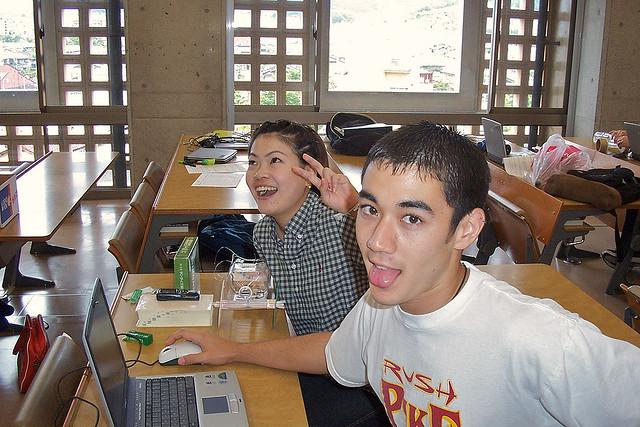Where are these young people seated?

Choices:
A) library
B) church
C) airport
D) school school 